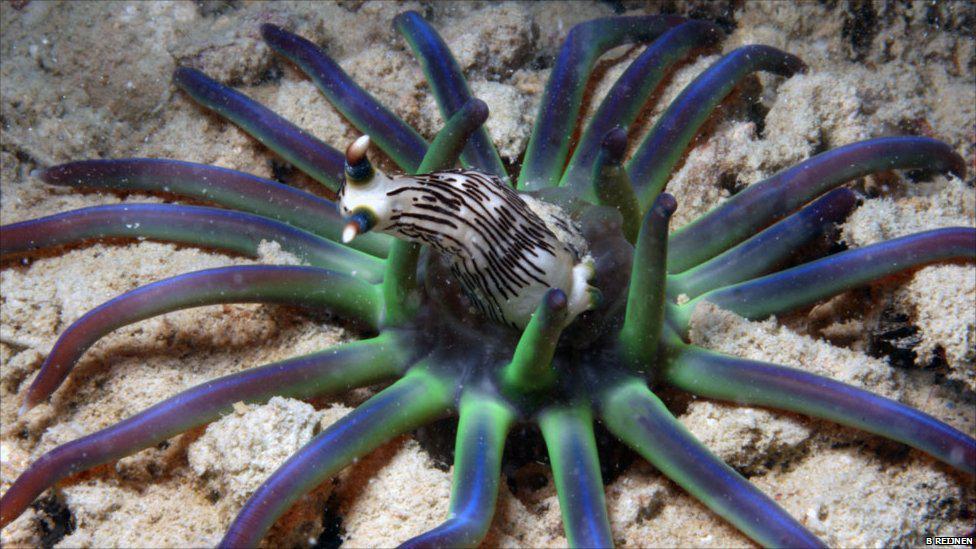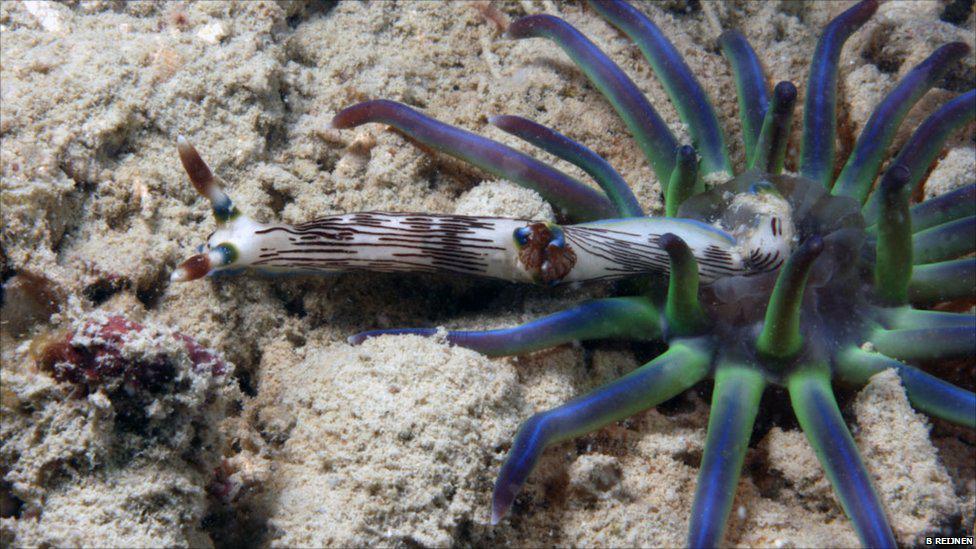The first image is the image on the left, the second image is the image on the right. Considering the images on both sides, is "The creatures in each image are the same color" valid? Answer yes or no. Yes. The first image is the image on the left, the second image is the image on the right. Considering the images on both sides, is "At least one image shows an anemone-type creature with tendrils in ombre green, blue and purple shades." valid? Answer yes or no. Yes. 